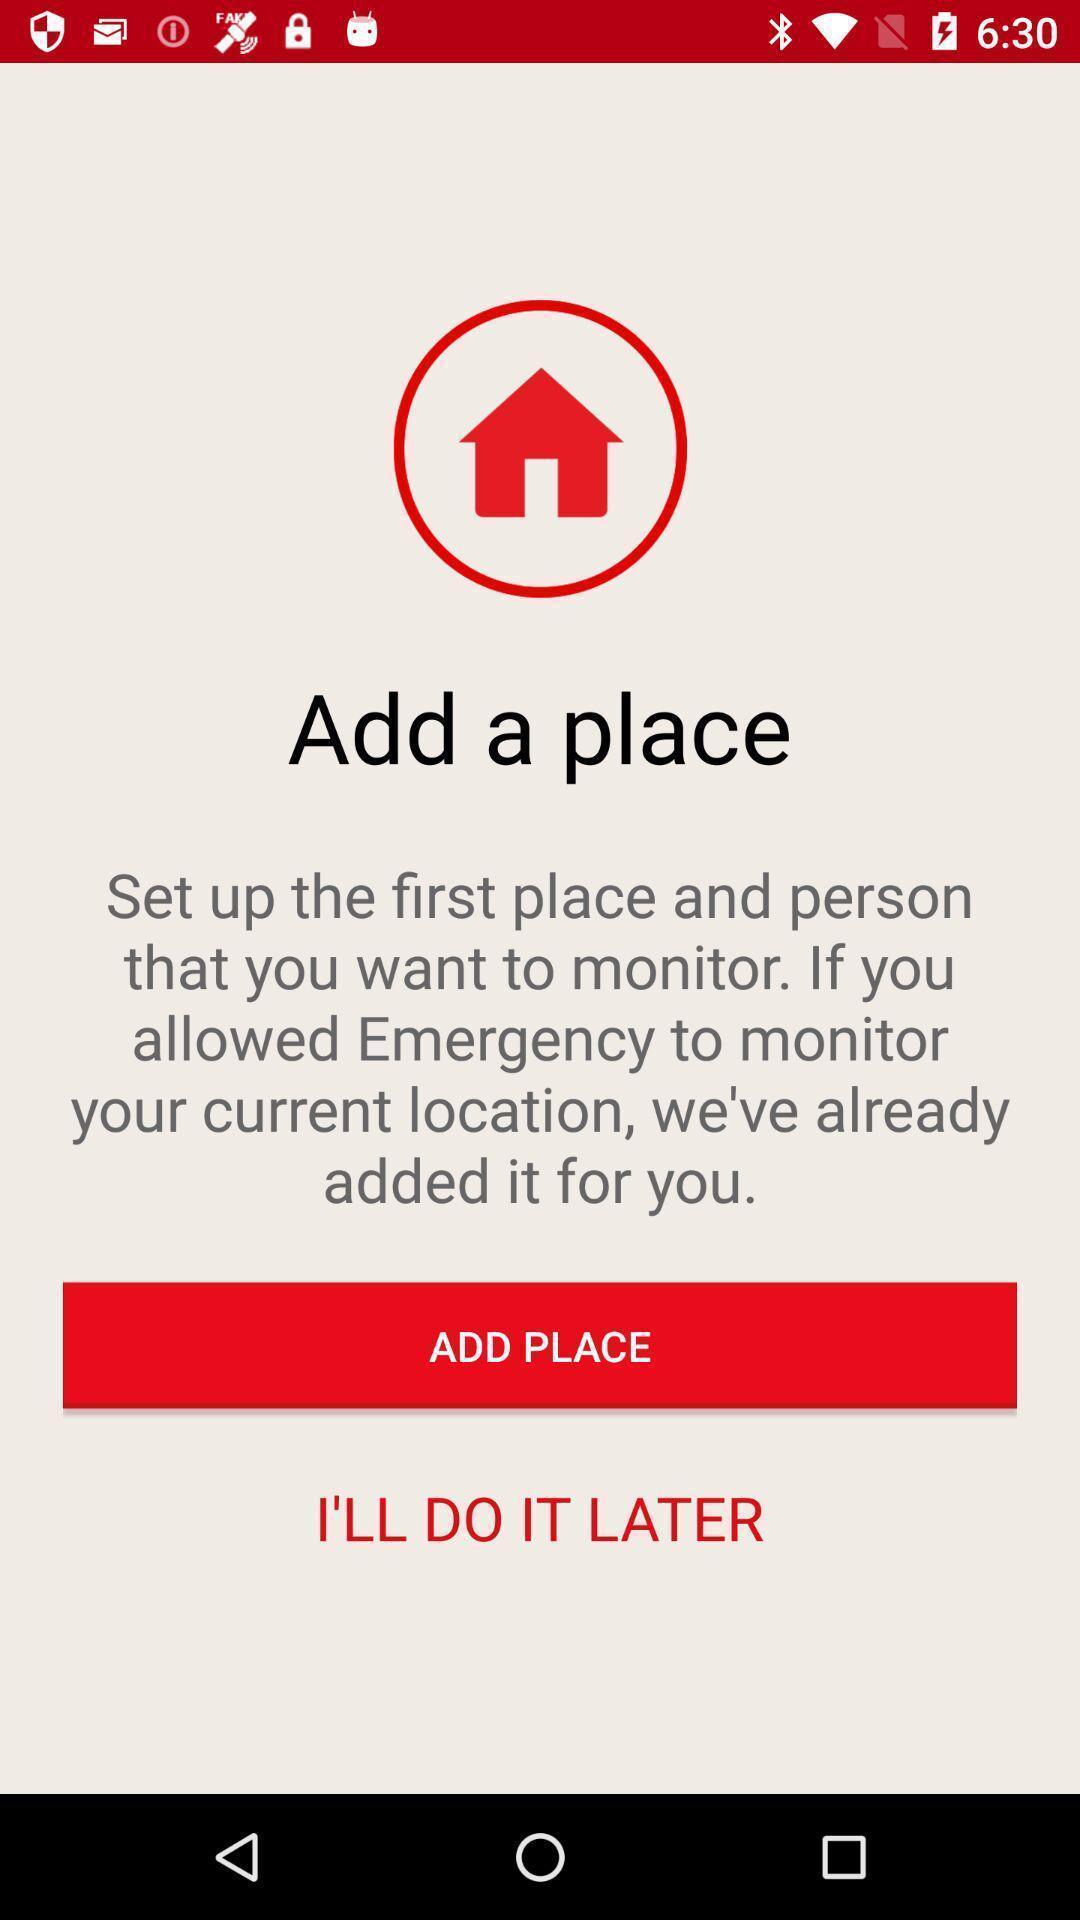Give me a summary of this screen capture. Screen shows add a place page. 